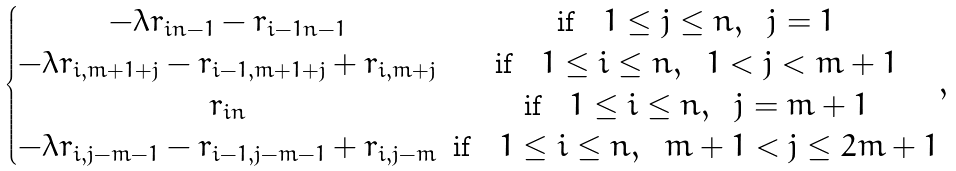Convert formula to latex. <formula><loc_0><loc_0><loc_500><loc_500>\begin{cases} \begin{matrix} - \lambda r _ { i n - 1 } - r _ { i - 1 n - 1 } & \text {if} \quad 1 \leq j \leq n , \ \ j = 1 \\ - \lambda r _ { i , m + 1 + j } - r _ { i - 1 , m + 1 + j } + r _ { i , m + j } & \text {if} \quad 1 \leq i \leq n , \ \ 1 < j < m + 1 \\ r _ { i n } & \text {if} \quad 1 \leq i \leq n , \ \ j = m + 1 \\ - \lambda r _ { i , j - m - 1 } - r _ { i - 1 , j - m - 1 } + r _ { i , j - m } & \text {if} \quad 1 \leq i \leq n , \ \ m + 1 < j \leq 2 m + 1 \\ \end{matrix} , \end{cases}</formula> 